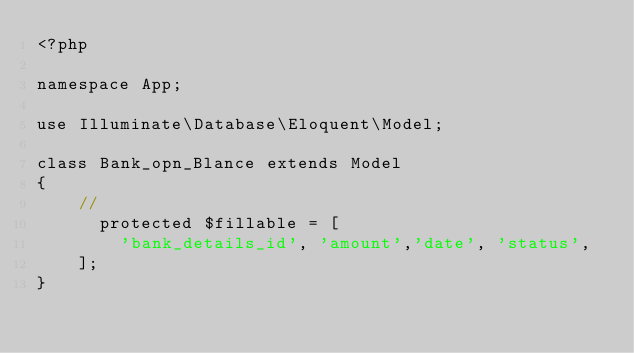Convert code to text. <code><loc_0><loc_0><loc_500><loc_500><_PHP_><?php

namespace App;

use Illuminate\Database\Eloquent\Model;

class Bank_opn_Blance extends Model
{
    //
      protected $fillable = [
        'bank_details_id', 'amount','date', 'status',
    ];
}
</code> 